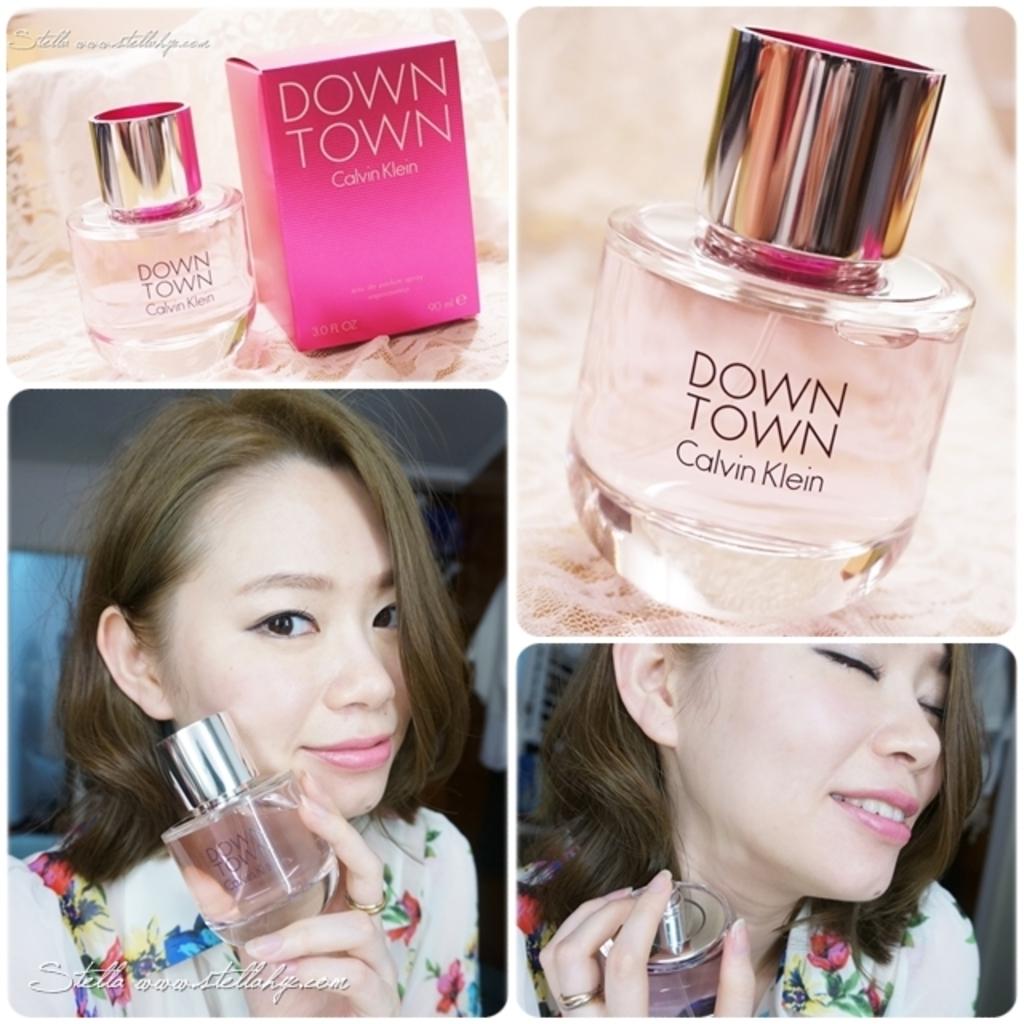What is the name of this calvin klein perfume?
Give a very brief answer. Down town. 